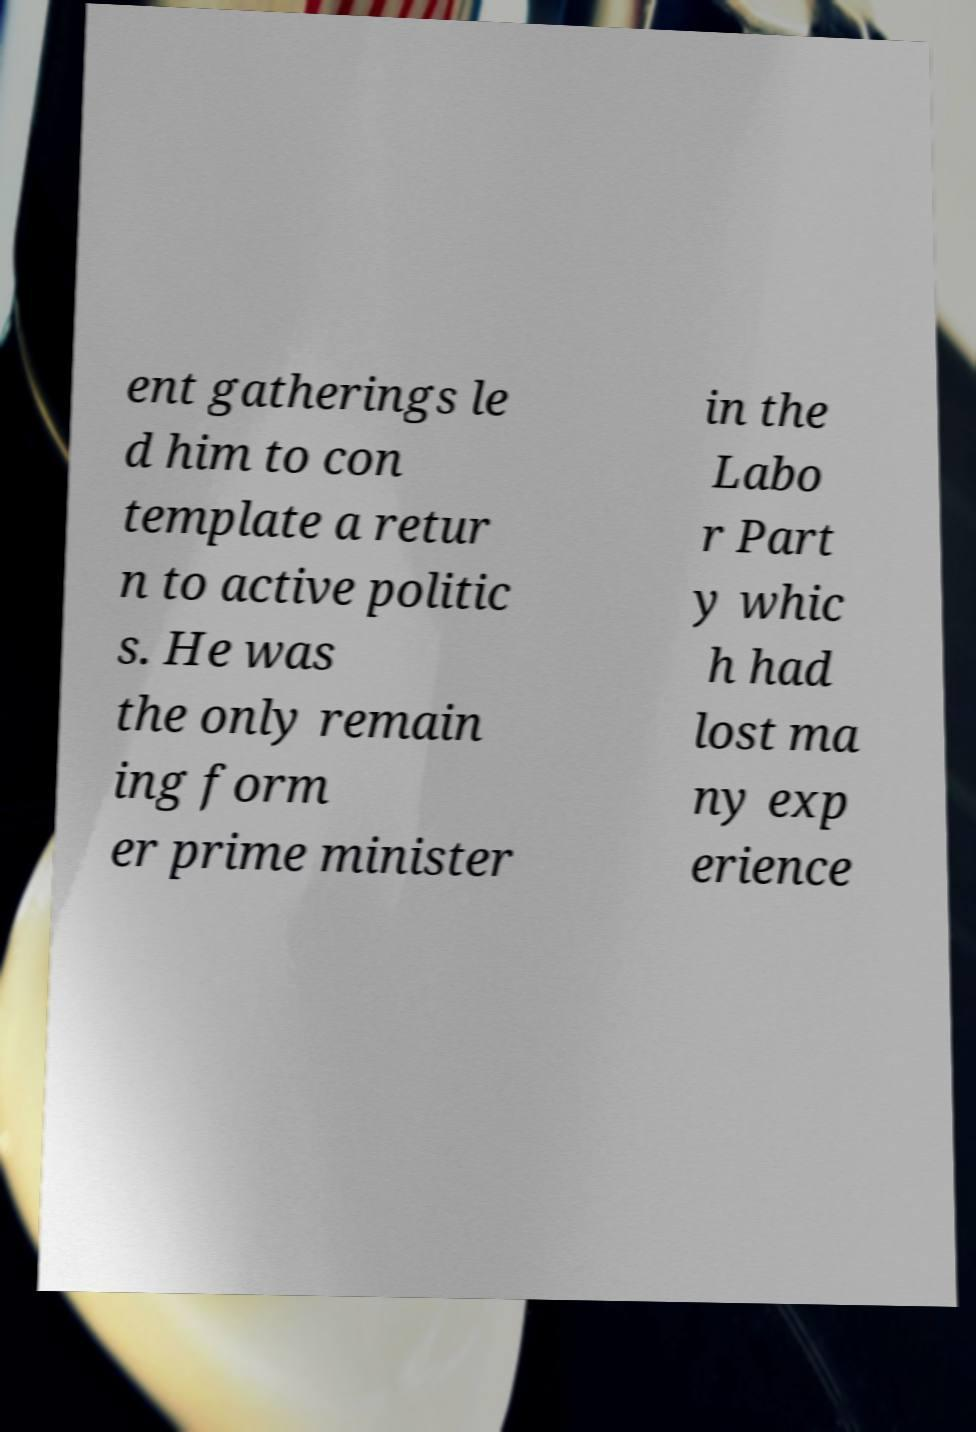I need the written content from this picture converted into text. Can you do that? ent gatherings le d him to con template a retur n to active politic s. He was the only remain ing form er prime minister in the Labo r Part y whic h had lost ma ny exp erience 